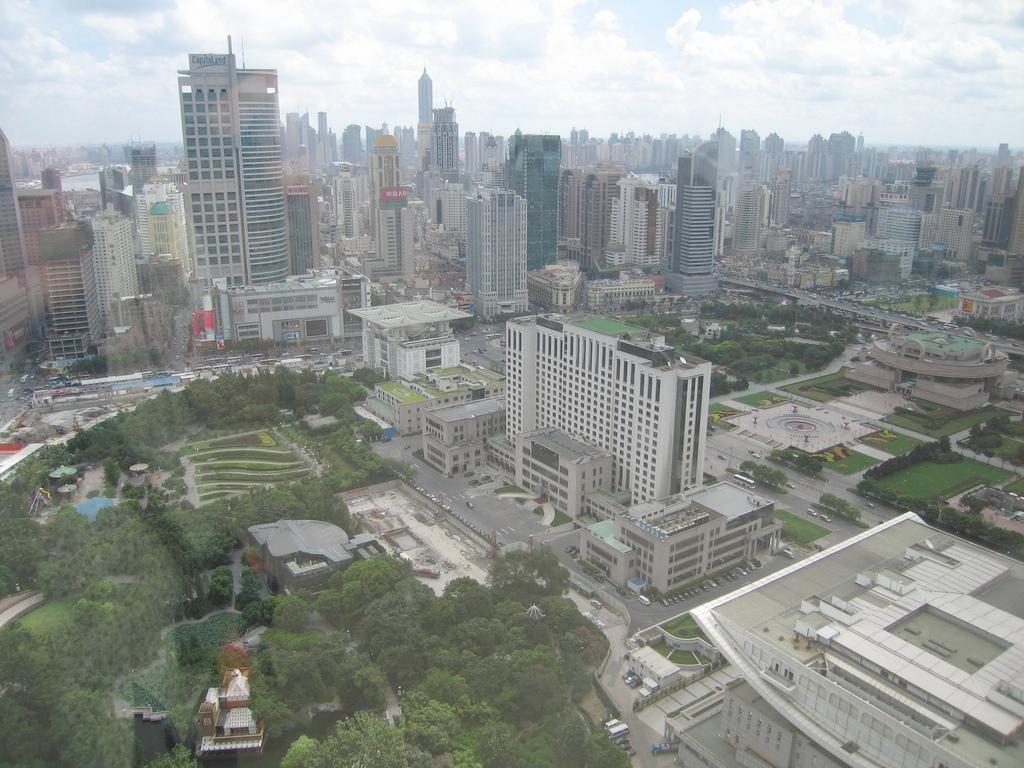What type of view is shown in the image? The image is an aerial view of a city. What structures can be seen in the image? There are buildings in the image. What type of vegetation is visible in the image? Trees and bushes are present in the image. What type of transportation infrastructure is visible in the image? Roads are present in the image, and vehicles are visible. What part of the natural environment is visible in the image? The sky is visible at the top of the image. What direction is the writing on the buildings pointing in the image? There is no writing visible on the buildings in the image. Can you see any oranges growing in the image? There are no oranges or orange trees present in the image. 